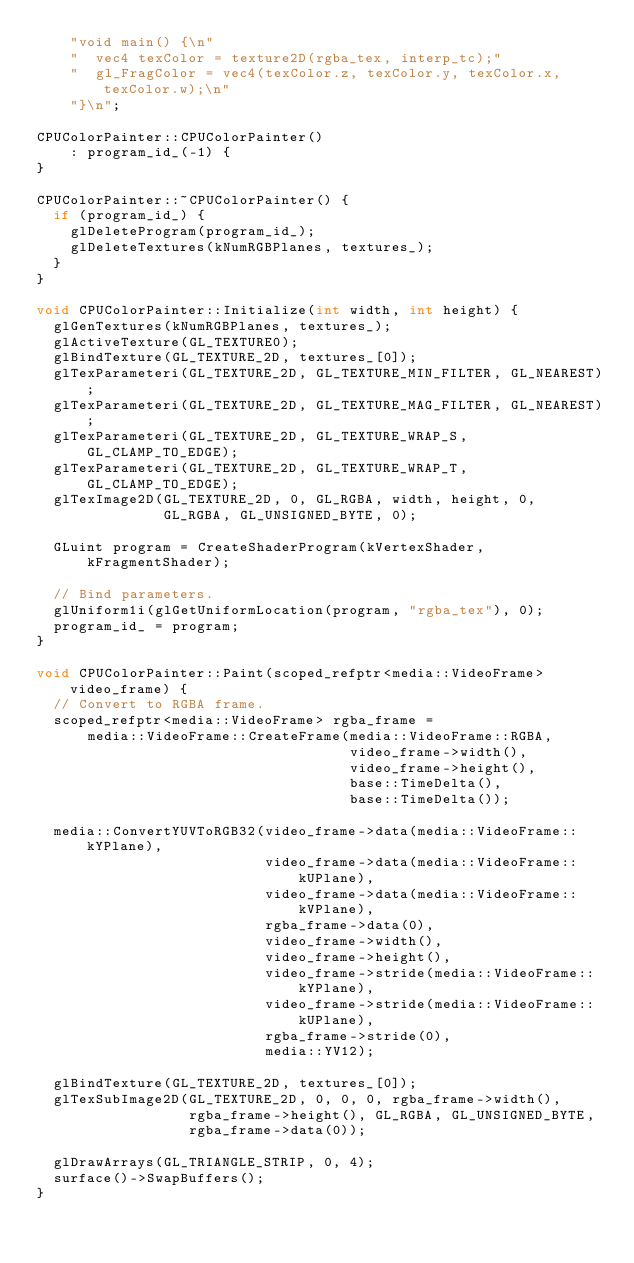<code> <loc_0><loc_0><loc_500><loc_500><_C++_>    "void main() {\n"
    "  vec4 texColor = texture2D(rgba_tex, interp_tc);"
    "  gl_FragColor = vec4(texColor.z, texColor.y, texColor.x, texColor.w);\n"
    "}\n";

CPUColorPainter::CPUColorPainter()
    : program_id_(-1) {
}

CPUColorPainter::~CPUColorPainter() {
  if (program_id_) {
    glDeleteProgram(program_id_);
    glDeleteTextures(kNumRGBPlanes, textures_);
  }
}

void CPUColorPainter::Initialize(int width, int height) {
  glGenTextures(kNumRGBPlanes, textures_);
  glActiveTexture(GL_TEXTURE0);
  glBindTexture(GL_TEXTURE_2D, textures_[0]);
  glTexParameteri(GL_TEXTURE_2D, GL_TEXTURE_MIN_FILTER, GL_NEAREST);
  glTexParameteri(GL_TEXTURE_2D, GL_TEXTURE_MAG_FILTER, GL_NEAREST);
  glTexParameteri(GL_TEXTURE_2D, GL_TEXTURE_WRAP_S, GL_CLAMP_TO_EDGE);
  glTexParameteri(GL_TEXTURE_2D, GL_TEXTURE_WRAP_T, GL_CLAMP_TO_EDGE);
  glTexImage2D(GL_TEXTURE_2D, 0, GL_RGBA, width, height, 0,
               GL_RGBA, GL_UNSIGNED_BYTE, 0);

  GLuint program = CreateShaderProgram(kVertexShader, kFragmentShader);

  // Bind parameters.
  glUniform1i(glGetUniformLocation(program, "rgba_tex"), 0);
  program_id_ = program;
}

void CPUColorPainter::Paint(scoped_refptr<media::VideoFrame> video_frame) {
  // Convert to RGBA frame.
  scoped_refptr<media::VideoFrame> rgba_frame =
      media::VideoFrame::CreateFrame(media::VideoFrame::RGBA,
                                     video_frame->width(),
                                     video_frame->height(),
                                     base::TimeDelta(),
                                     base::TimeDelta());

  media::ConvertYUVToRGB32(video_frame->data(media::VideoFrame::kYPlane),
                           video_frame->data(media::VideoFrame::kUPlane),
                           video_frame->data(media::VideoFrame::kVPlane),
                           rgba_frame->data(0),
                           video_frame->width(),
                           video_frame->height(),
                           video_frame->stride(media::VideoFrame::kYPlane),
                           video_frame->stride(media::VideoFrame::kUPlane),
                           rgba_frame->stride(0),
                           media::YV12);

  glBindTexture(GL_TEXTURE_2D, textures_[0]);
  glTexSubImage2D(GL_TEXTURE_2D, 0, 0, 0, rgba_frame->width(),
                  rgba_frame->height(), GL_RGBA, GL_UNSIGNED_BYTE,
                  rgba_frame->data(0));

  glDrawArrays(GL_TRIANGLE_STRIP, 0, 4);
  surface()->SwapBuffers();
}
</code> 